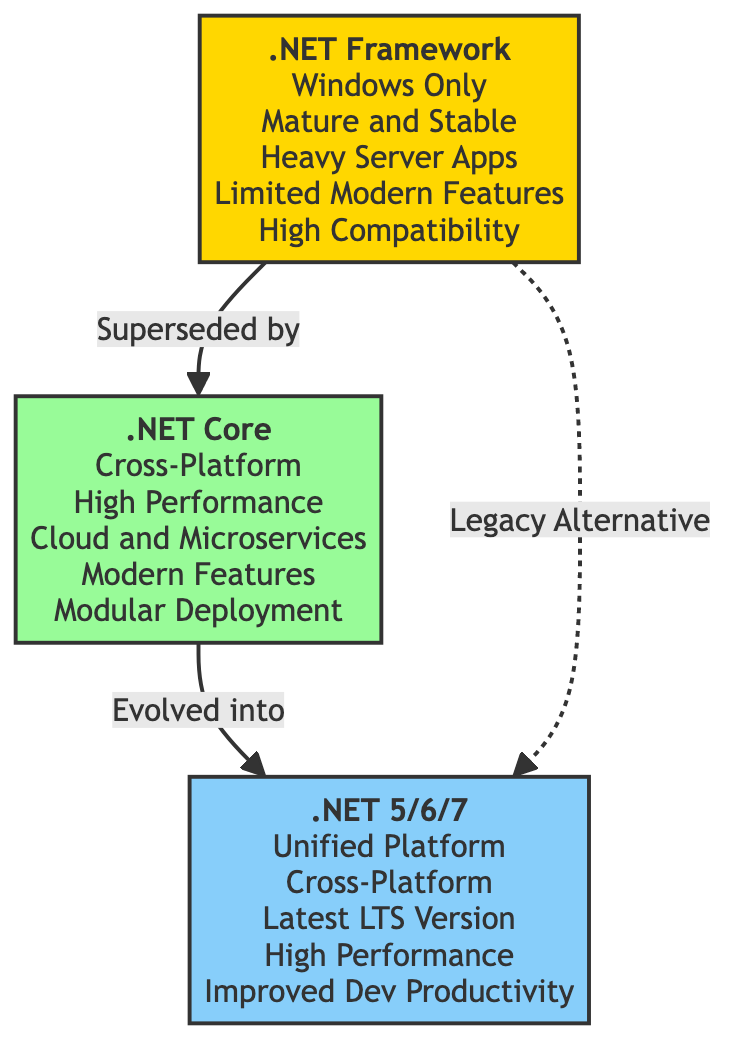What is the operating system limitation of .NET Framework? The diagram indicates that .NET Framework is labeled "Windows Only." This suggests that it can only be used on Windows operating systems.
Answer: Windows Only How many main runtime environments are represented in the diagram? By counting the nodes in the diagram, we see three main environments: .NET Framework, .NET Core, and .NET 5/6/7, confirming a total of three.
Answer: Three What feature differentiates .NET Core from .NET Framework? The diagram highlights that .NET Core has "Cross-Platform" as a feature, suggesting it is not limited to just one operating system, contrasting its predecessor, .NET Framework.
Answer: Cross-Platform Which runtime environment is described as "Unified Platform"? The label in the diagram shows that .NET 5/6/7 is defined as the "Unified Platform," indicating it consolidates earlier frameworks and capabilities into a single environment.
Answer: .NET 5/6/7 What type of applications is .NET Framework primarily used for? The diagram notes that .NET Framework is suited for "Heavy Server Apps," which indicates its primary application context within enterprise-level software development.
Answer: Heavy Server Apps What does the arrow from .NET Core to .NET 5/6/7 imply? The arrow labeled "Evolved into" signifies that .NET Core is a precursor to .NET 5/6/7, indicating a continuation and improvement of features and capabilities.
Answer: Evolved into Which runtime environment offers "Improved Dev Productivity"? According to the diagram, the phrase "Improved Dev Productivity" is attributed to .NET 5/6/7, highlighting this as a significant advantage of this newer version.
Answer: .NET 5/6/7 What relationship does the dashed line indicate between .NET Framework and .NET 5/6/7? The dashed line is labeled "Legacy Alternative," suggesting that while .NET Framework is an older system, it still serves as an alternative to .NET 5/6/7, albeit in a more limited capacity.
Answer: Legacy Alternative What color represents .NET Core in the diagram? The diagram denotes .NET Core with a green fill color, specifically coded as #98fb98, which visually differentiates it from the other frameworks in the comparison.
Answer: Green 